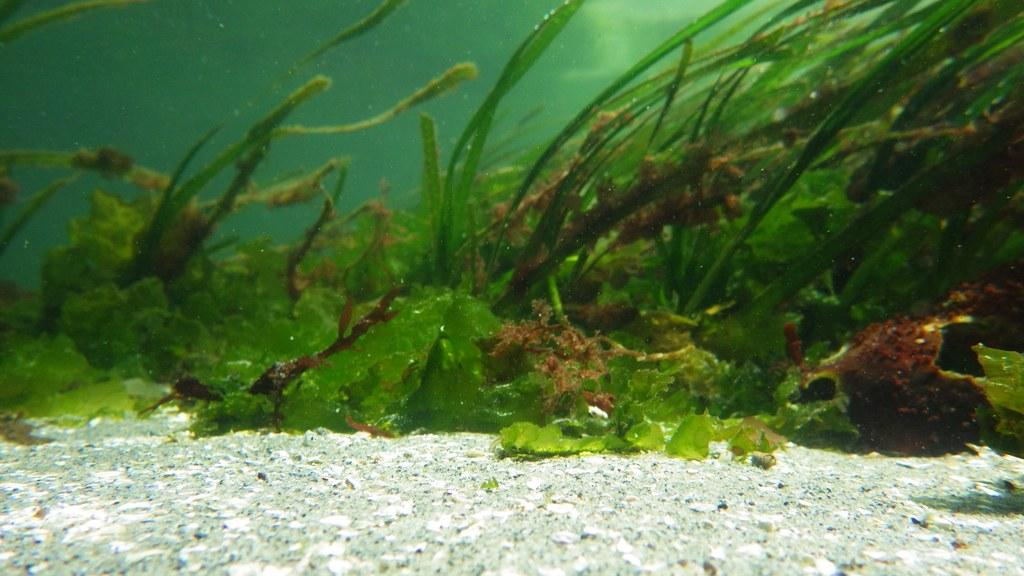What type of environment is shown in the image? The image depicts a view under the sea. Can you describe any specific features of the underwater environment? Unfortunately, the provided facts do not include any specific features of the underwater environment. Are there any living organisms visible in the image? The provided facts do not mention any living organisms in the image. What type of operation is being performed in the town shown in the image? There is no town or operation present in the image, as it depicts a view under the sea. 